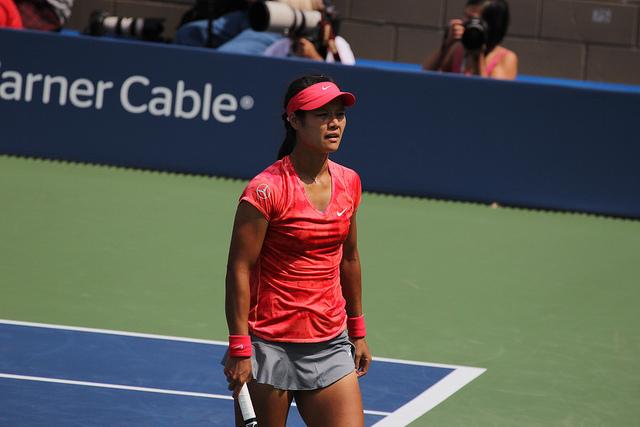What is about to happen?
Keep it brief. Tennis match. Is the woman hitting. the ball?
Give a very brief answer. No. What symbol is behind the player?
Concise answer only. Cable. What hand is she holding the racket in?
Concise answer only. Right. What is she wearing on her head?
Write a very short answer. Visor. What brand of clothing is she wearing?
Concise answer only. Nike. 